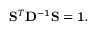Convert formula to latex. <formula><loc_0><loc_0><loc_500><loc_500>S ^ { T } D ^ { - 1 } S = 1 .</formula> 